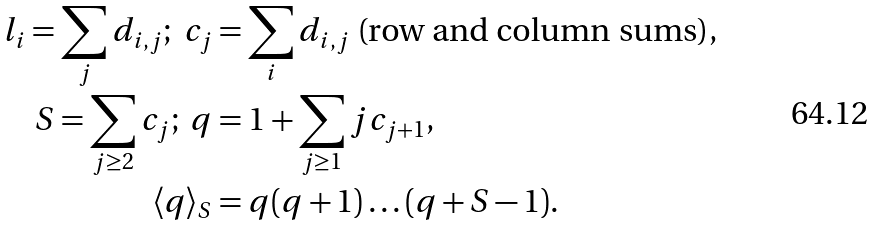<formula> <loc_0><loc_0><loc_500><loc_500>l _ { i } = \sum _ { j } d _ { i , j } ; \ c _ { j } & = \sum _ { i } d _ { i , j } \text { (row and column sums)} , \\ S = \sum _ { j \geq 2 } c _ { j } ; \ q & = 1 + \sum _ { j \geq 1 } j c _ { j + 1 } , \\ \langle q \rangle _ { S } & = q ( q + 1 ) \dots ( q + S - 1 ) .</formula> 